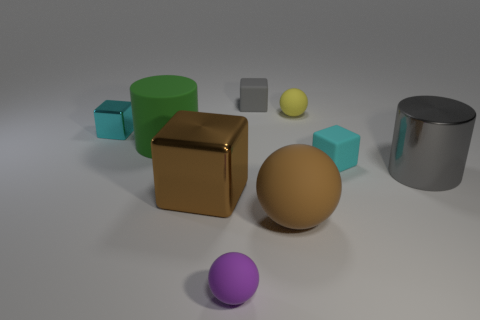There is a thing that is the same color as the big metallic cube; what is its shape?
Provide a succinct answer. Sphere. The gray cube that is made of the same material as the small yellow object is what size?
Make the answer very short. Small. Is there any other thing that is the same color as the large rubber cylinder?
Offer a very short reply. No. There is a cyan block that is in front of the cylinder on the left side of the gray object that is behind the gray cylinder; what is it made of?
Your response must be concise. Rubber. What number of metallic things are either cubes or red objects?
Offer a terse response. 2. Is the big sphere the same color as the big shiny cylinder?
Your response must be concise. No. Is there any other thing that is the same material as the large green cylinder?
Your answer should be very brief. Yes. What number of objects are either rubber spheres or shiny objects that are in front of the big green cylinder?
Provide a short and direct response. 5. There is a cube that is behind the yellow rubber object; is it the same size as the brown matte object?
Provide a succinct answer. No. What number of other things are the same shape as the big gray thing?
Offer a terse response. 1. 